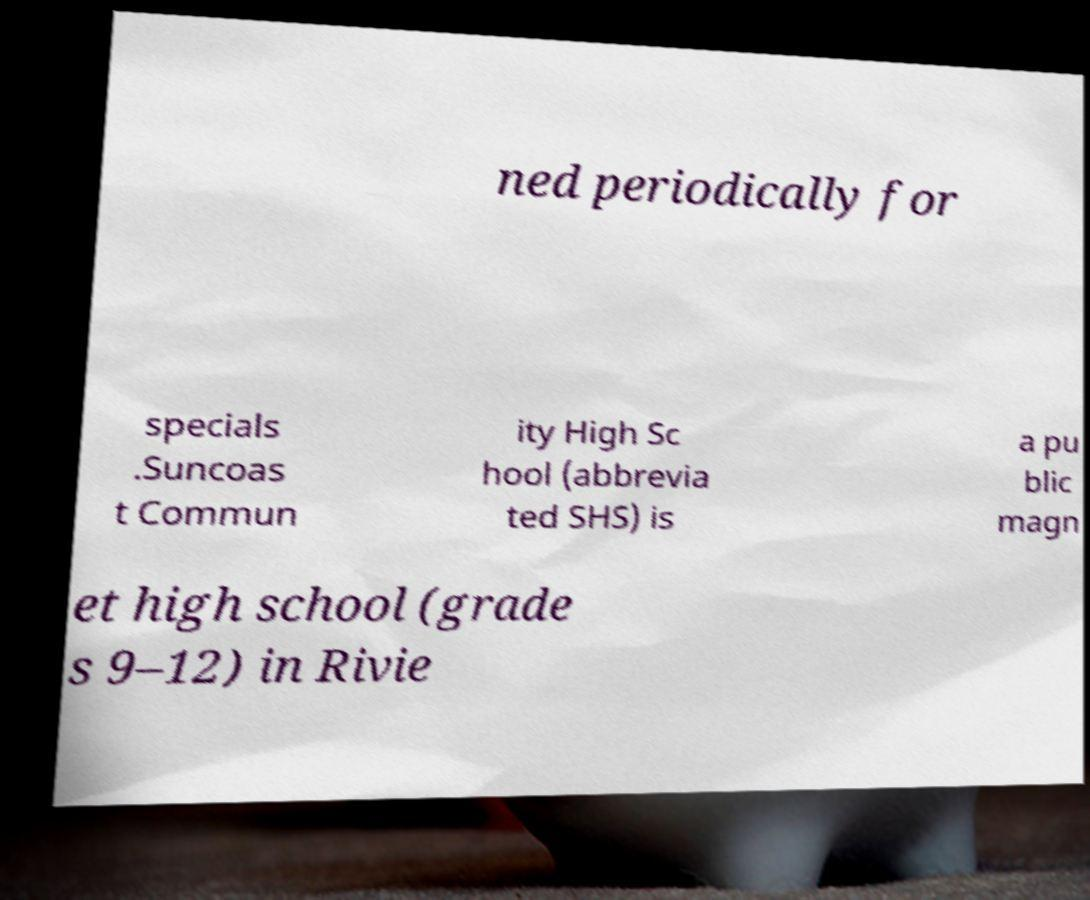There's text embedded in this image that I need extracted. Can you transcribe it verbatim? ned periodically for specials .Suncoas t Commun ity High Sc hool (abbrevia ted SHS) is a pu blic magn et high school (grade s 9–12) in Rivie 